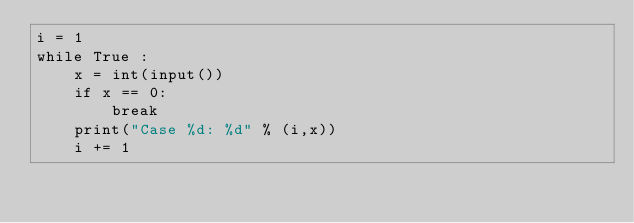Convert code to text. <code><loc_0><loc_0><loc_500><loc_500><_Python_>i = 1
while True :
    x = int(input())
    if x == 0:
        break
    print("Case %d: %d" % (i,x))
    i += 1
</code> 